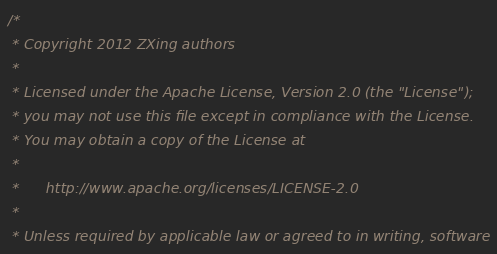Convert code to text. <code><loc_0><loc_0><loc_500><loc_500><_C_>/*
 * Copyright 2012 ZXing authors
 *
 * Licensed under the Apache License, Version 2.0 (the "License");
 * you may not use this file except in compliance with the License.
 * You may obtain a copy of the License at
 *
 *      http://www.apache.org/licenses/LICENSE-2.0
 *
 * Unless required by applicable law or agreed to in writing, software</code> 